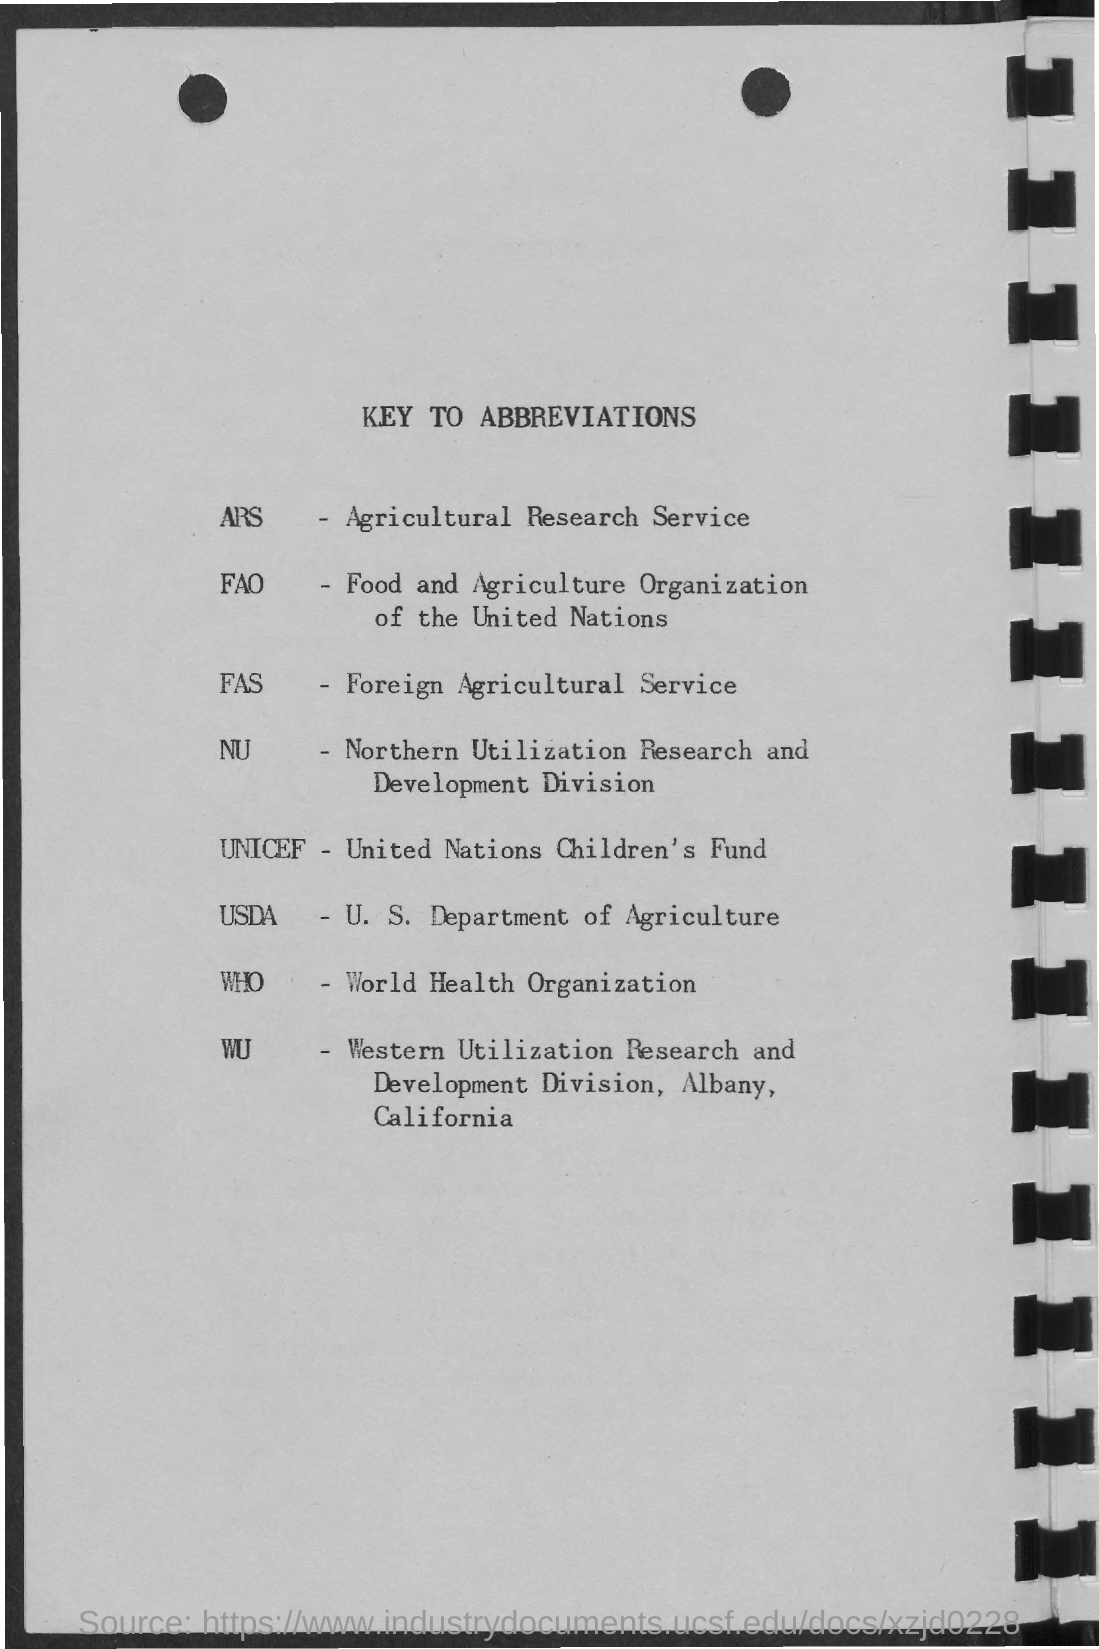Highlight a few significant elements in this photo. The full form of ARS is the Agricultural Research Service. The acronym "FAS" stands for "Foreign Agricultural Service. The abbreviation for the U.S. Department of Agriculture is USDA. The World Health Organization, commonly abbreviated as WHO, is a specialized agency of the United Nations that is responsible for improving global health. UNICEF, which stands for United Nations Children's Fund, is an organization dedicated to promoting and protecting the rights of children globally. 